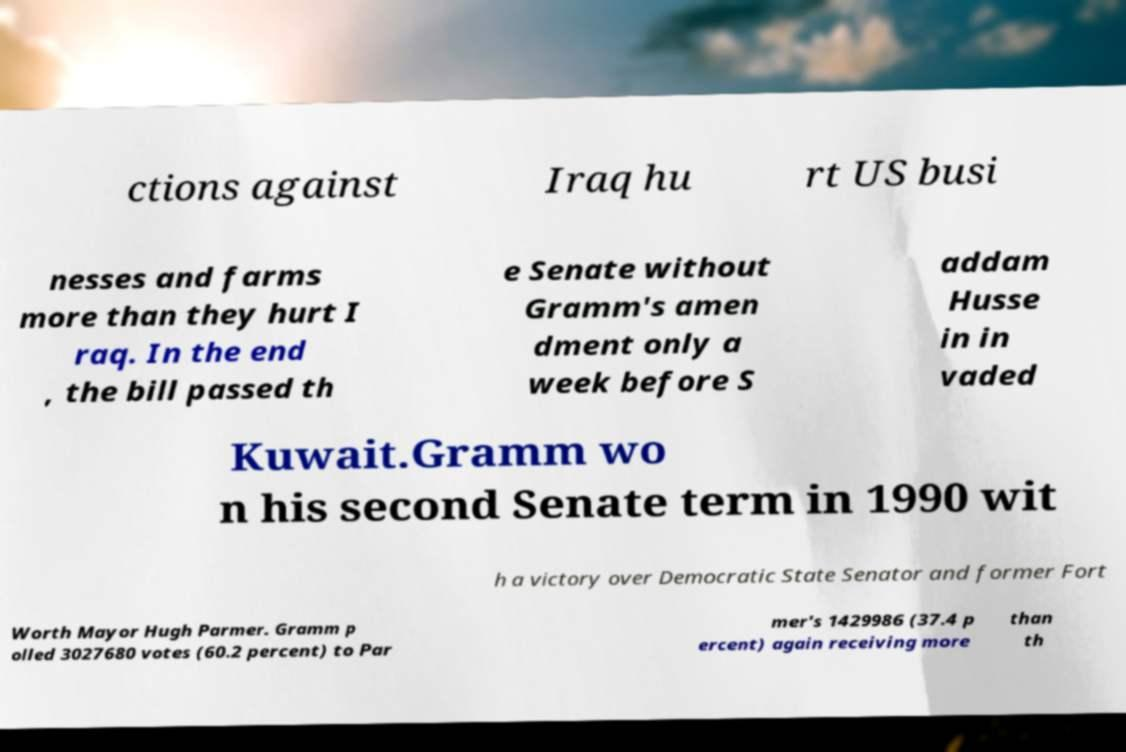Please identify and transcribe the text found in this image. ctions against Iraq hu rt US busi nesses and farms more than they hurt I raq. In the end , the bill passed th e Senate without Gramm's amen dment only a week before S addam Husse in in vaded Kuwait.Gramm wo n his second Senate term in 1990 wit h a victory over Democratic State Senator and former Fort Worth Mayor Hugh Parmer. Gramm p olled 3027680 votes (60.2 percent) to Par mer's 1429986 (37.4 p ercent) again receiving more than th 